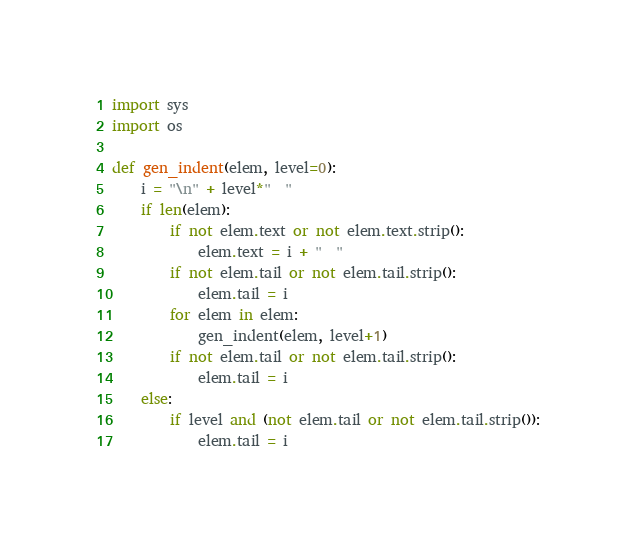<code> <loc_0><loc_0><loc_500><loc_500><_Python_>import sys
import os

def gen_indent(elem, level=0):
    i = "\n" + level*"  "
    if len(elem):
        if not elem.text or not elem.text.strip():
            elem.text = i + "  "
        if not elem.tail or not elem.tail.strip():
            elem.tail = i
        for elem in elem:
            gen_indent(elem, level+1)
        if not elem.tail or not elem.tail.strip():
            elem.tail = i
    else:
        if level and (not elem.tail or not elem.tail.strip()):
            elem.tail = i
</code> 